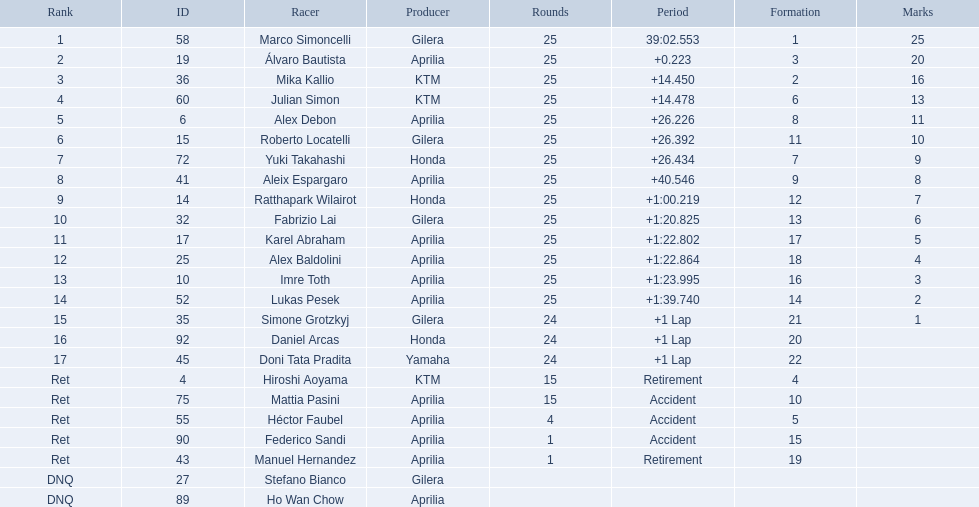How many laps did hiroshi aoyama perform? 15. Could you help me parse every detail presented in this table? {'header': ['Rank', 'ID', 'Racer', 'Producer', 'Rounds', 'Period', 'Formation', 'Marks'], 'rows': [['1', '58', 'Marco Simoncelli', 'Gilera', '25', '39:02.553', '1', '25'], ['2', '19', 'Álvaro Bautista', 'Aprilia', '25', '+0.223', '3', '20'], ['3', '36', 'Mika Kallio', 'KTM', '25', '+14.450', '2', '16'], ['4', '60', 'Julian Simon', 'KTM', '25', '+14.478', '6', '13'], ['5', '6', 'Alex Debon', 'Aprilia', '25', '+26.226', '8', '11'], ['6', '15', 'Roberto Locatelli', 'Gilera', '25', '+26.392', '11', '10'], ['7', '72', 'Yuki Takahashi', 'Honda', '25', '+26.434', '7', '9'], ['8', '41', 'Aleix Espargaro', 'Aprilia', '25', '+40.546', '9', '8'], ['9', '14', 'Ratthapark Wilairot', 'Honda', '25', '+1:00.219', '12', '7'], ['10', '32', 'Fabrizio Lai', 'Gilera', '25', '+1:20.825', '13', '6'], ['11', '17', 'Karel Abraham', 'Aprilia', '25', '+1:22.802', '17', '5'], ['12', '25', 'Alex Baldolini', 'Aprilia', '25', '+1:22.864', '18', '4'], ['13', '10', 'Imre Toth', 'Aprilia', '25', '+1:23.995', '16', '3'], ['14', '52', 'Lukas Pesek', 'Aprilia', '25', '+1:39.740', '14', '2'], ['15', '35', 'Simone Grotzkyj', 'Gilera', '24', '+1 Lap', '21', '1'], ['16', '92', 'Daniel Arcas', 'Honda', '24', '+1 Lap', '20', ''], ['17', '45', 'Doni Tata Pradita', 'Yamaha', '24', '+1 Lap', '22', ''], ['Ret', '4', 'Hiroshi Aoyama', 'KTM', '15', 'Retirement', '4', ''], ['Ret', '75', 'Mattia Pasini', 'Aprilia', '15', 'Accident', '10', ''], ['Ret', '55', 'Héctor Faubel', 'Aprilia', '4', 'Accident', '5', ''], ['Ret', '90', 'Federico Sandi', 'Aprilia', '1', 'Accident', '15', ''], ['Ret', '43', 'Manuel Hernandez', 'Aprilia', '1', 'Retirement', '19', ''], ['DNQ', '27', 'Stefano Bianco', 'Gilera', '', '', '', ''], ['DNQ', '89', 'Ho Wan Chow', 'Aprilia', '', '', '', '']]} How many laps did marco simoncelli perform? 25. Who performed more laps out of hiroshi aoyama and marco 
simoncelli? Marco Simoncelli. 